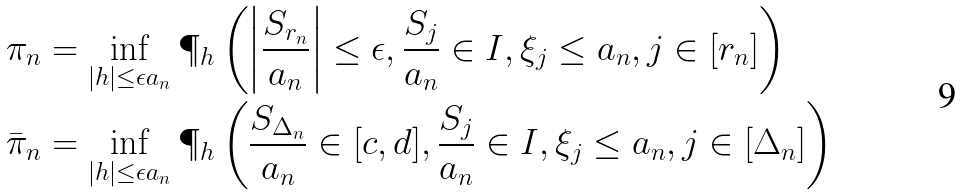<formula> <loc_0><loc_0><loc_500><loc_500>\pi _ { n } & = \inf _ { | h | \leq \epsilon a _ { n } } \P _ { h } \left ( \left | \frac { S _ { r _ { n } } } { a _ { n } } \right | \leq \epsilon , \frac { S _ { j } } { a _ { n } } \in I , \xi _ { j } \leq a _ { n } , j \in [ r _ { n } ] \right ) \\ \bar { \pi } _ { n } & = \inf _ { | h | \leq \epsilon a _ { n } } \P _ { h } \left ( \frac { S _ { \Delta _ { n } } } { a _ { n } } \in [ c , d ] , \frac { S _ { j } } { a _ { n } } \in I , \xi _ { j } \leq a _ { n } , j \in [ \Delta _ { n } ] \right )</formula> 